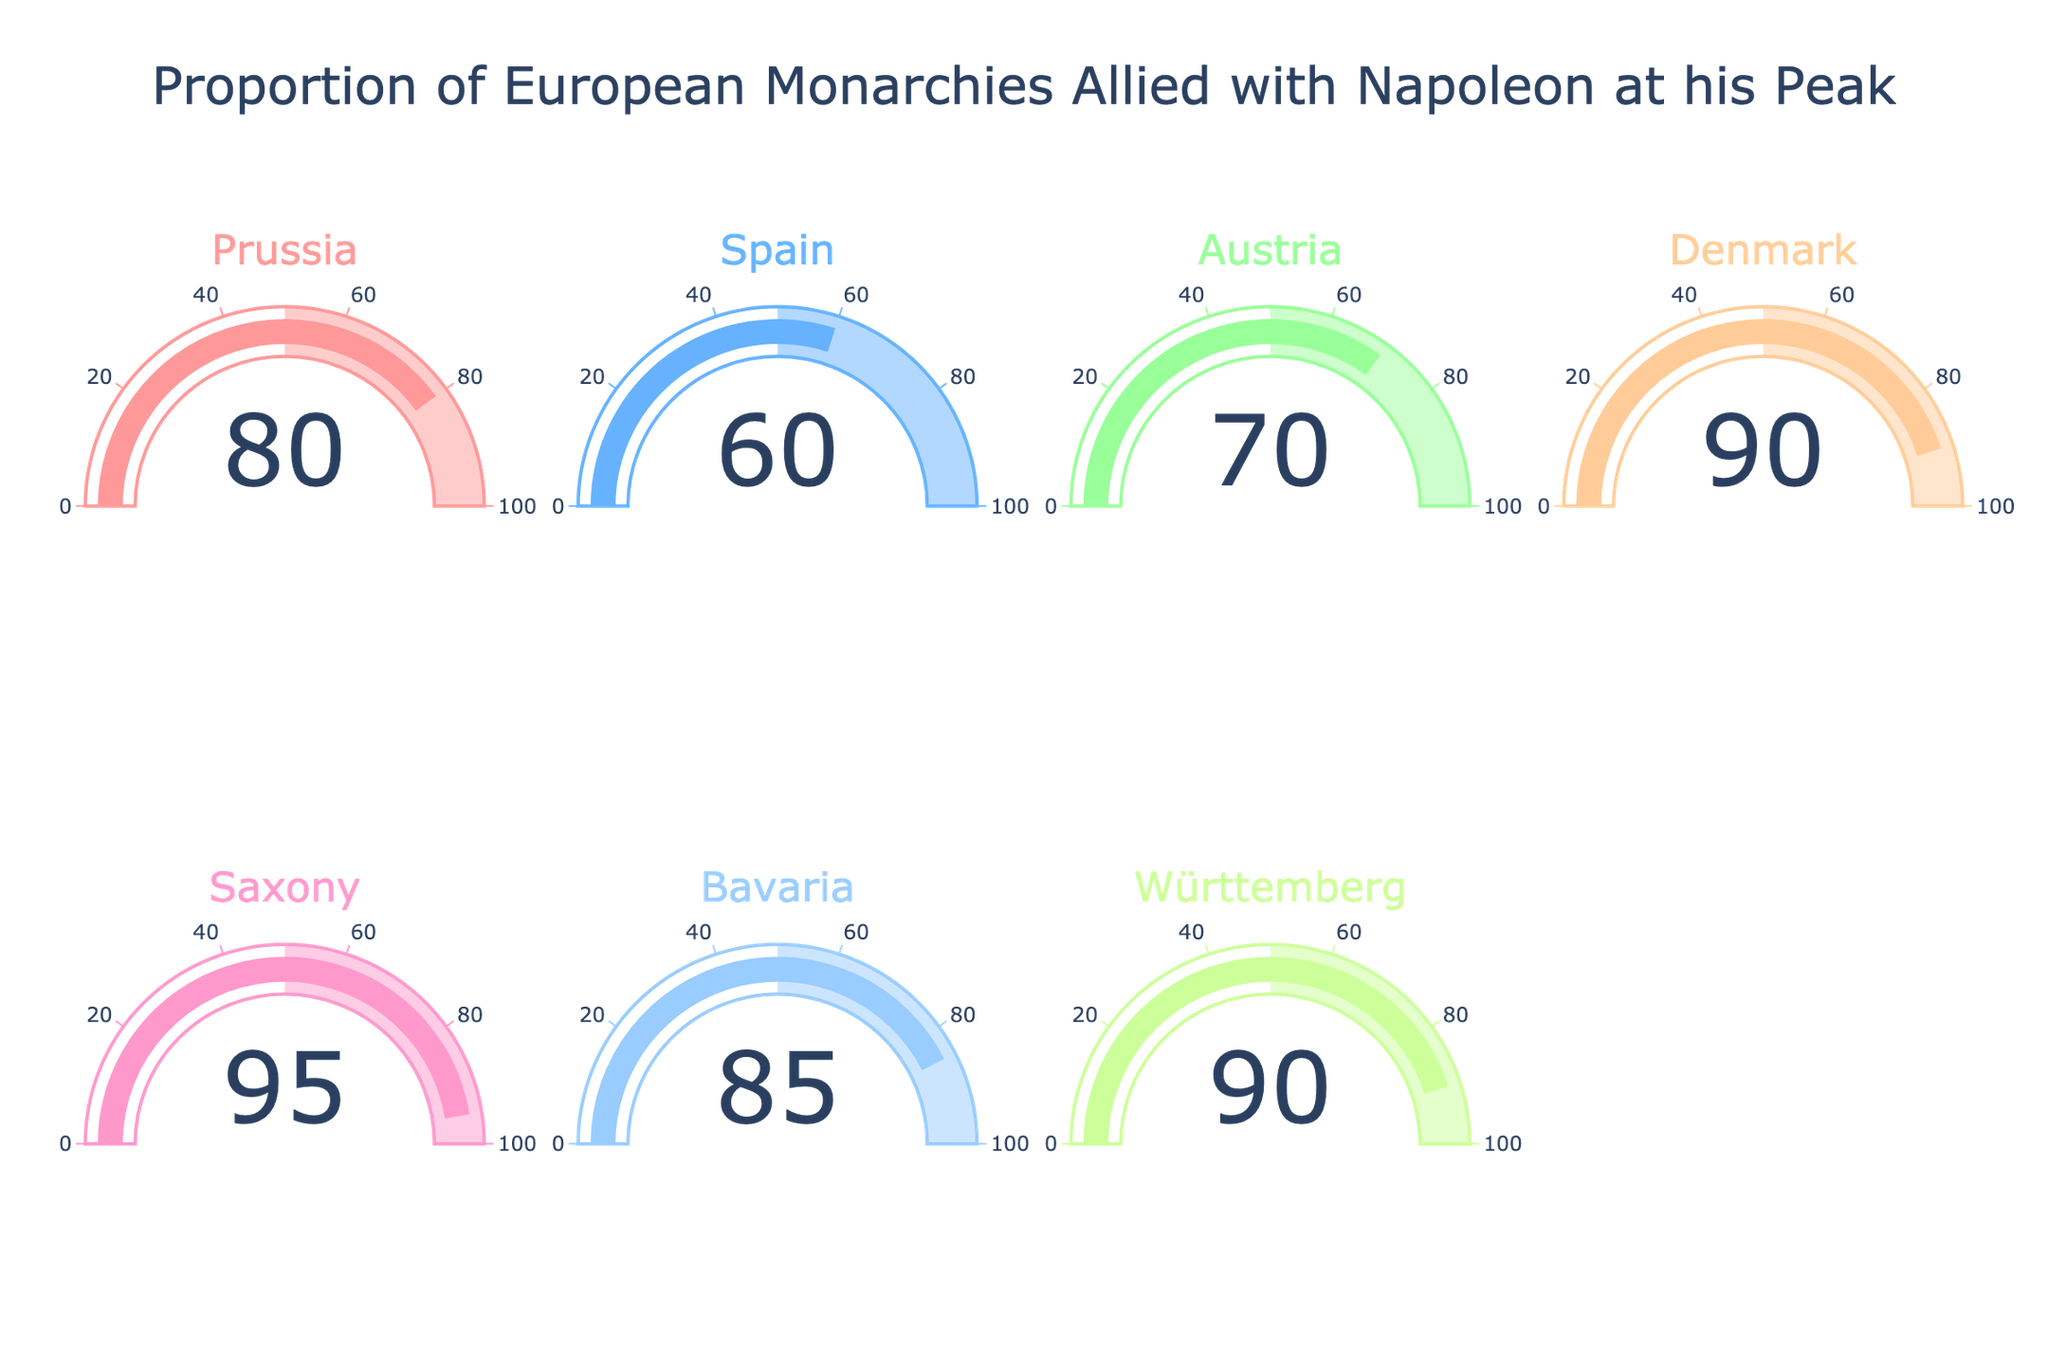What is the title of the figure? The title is displayed at the top of the figure. It reads "Proportion of European Monarchies Allied with Napoleon at his Peak".
Answer: Proportion of European Monarchies Allied with Napoleon at his Peak How many countries are represented in the figure? There are seven gauge charts shown in the figure, each representing a different country. You can count the number of gauge charts or look at the different country names.
Answer: 7 Which country has the highest proportion of alliance with Napoleon? The gauge chart for Saxony shows the highest value. The needle points at 95%.
Answer: Saxony Which country has the lowest proportion of alliance with Napoleon? The gauge chart for Spain shows the lowest value. The needle points at 60%.
Answer: Spain What's the average proportion of European monarchies allied with Napoleon? Add up all the proportions and divide by the number of countries. (0.8 + 0.6 + 0.7 + 0.9 + 0.95 + 0.85 + 0.9) / 7 = 5.7 / 7 = 0.814 (approx. 81.4%).
Answer: 81.4% What's the difference in the proportion of alliance between Prussia and Spain? Subtract the proportion of Spain from that of Prussia. 80% - 60% = 20%.
Answer: 20% Which countries have a proportion of alliance greater than 80%? Check each gauge chart and identify those with proportions greater than 80%. Prussia (80%, included because it meets the threshold), Denmark (90%), Saxony (95%), Bavaria (85%), and Württemberg (90%).
Answer: Prussia, Denmark, Saxony, Bavaria, Württemberg How is the proportion of Bavaria's alliance compared to Austria's? The gauge chart for Bavaria shows 85%, and for Austria, it shows 70%. Bavaria's proportion is higher by 15%.
Answer: Bavaria's is higher What is the median proportion of the alliances? Arrange the proportions in ascending order and find the middle value. Ordered: 60%, 70%, 80%, 85%, 90%, 90%, 95%. The median is the 4th value, which is 85%.
Answer: 85% Which countries have an equal proportion of alliance with Napoleon? Check each gauge chart to find those with the same value. Denmark and Württemberg both have 90%.
Answer: Denmark and Württemberg 